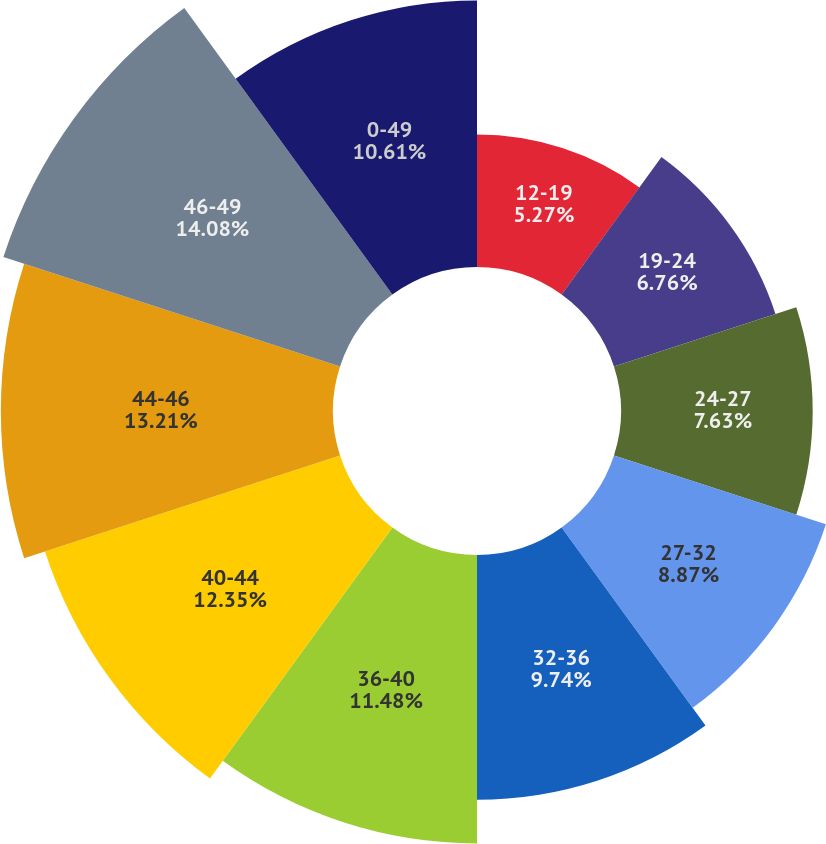Convert chart to OTSL. <chart><loc_0><loc_0><loc_500><loc_500><pie_chart><fcel>12-19<fcel>19-24<fcel>24-27<fcel>27-32<fcel>32-36<fcel>36-40<fcel>40-44<fcel>44-46<fcel>46-49<fcel>0-49<nl><fcel>5.27%<fcel>6.76%<fcel>7.63%<fcel>8.87%<fcel>9.74%<fcel>11.48%<fcel>12.35%<fcel>13.22%<fcel>14.09%<fcel>10.61%<nl></chart> 